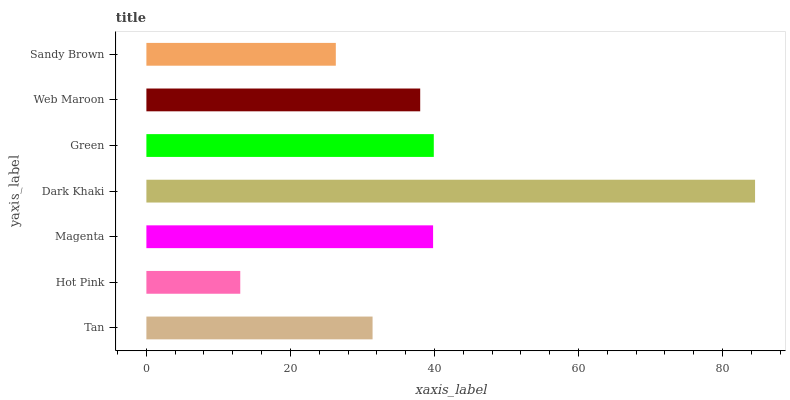Is Hot Pink the minimum?
Answer yes or no. Yes. Is Dark Khaki the maximum?
Answer yes or no. Yes. Is Magenta the minimum?
Answer yes or no. No. Is Magenta the maximum?
Answer yes or no. No. Is Magenta greater than Hot Pink?
Answer yes or no. Yes. Is Hot Pink less than Magenta?
Answer yes or no. Yes. Is Hot Pink greater than Magenta?
Answer yes or no. No. Is Magenta less than Hot Pink?
Answer yes or no. No. Is Web Maroon the high median?
Answer yes or no. Yes. Is Web Maroon the low median?
Answer yes or no. Yes. Is Tan the high median?
Answer yes or no. No. Is Hot Pink the low median?
Answer yes or no. No. 